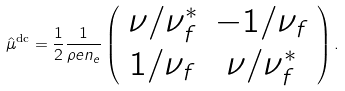<formula> <loc_0><loc_0><loc_500><loc_500>\hat { \mu } ^ { \text {dc} } = \frac { 1 } { 2 } \frac { 1 } { \rho e n _ { e } } \left ( \begin{array} { c c } \nu / \nu _ { f } ^ { * } & - 1 / \nu _ { f } \\ 1 / \nu _ { f } & \nu / \nu _ { f } ^ { * } \end{array} \right ) .</formula> 